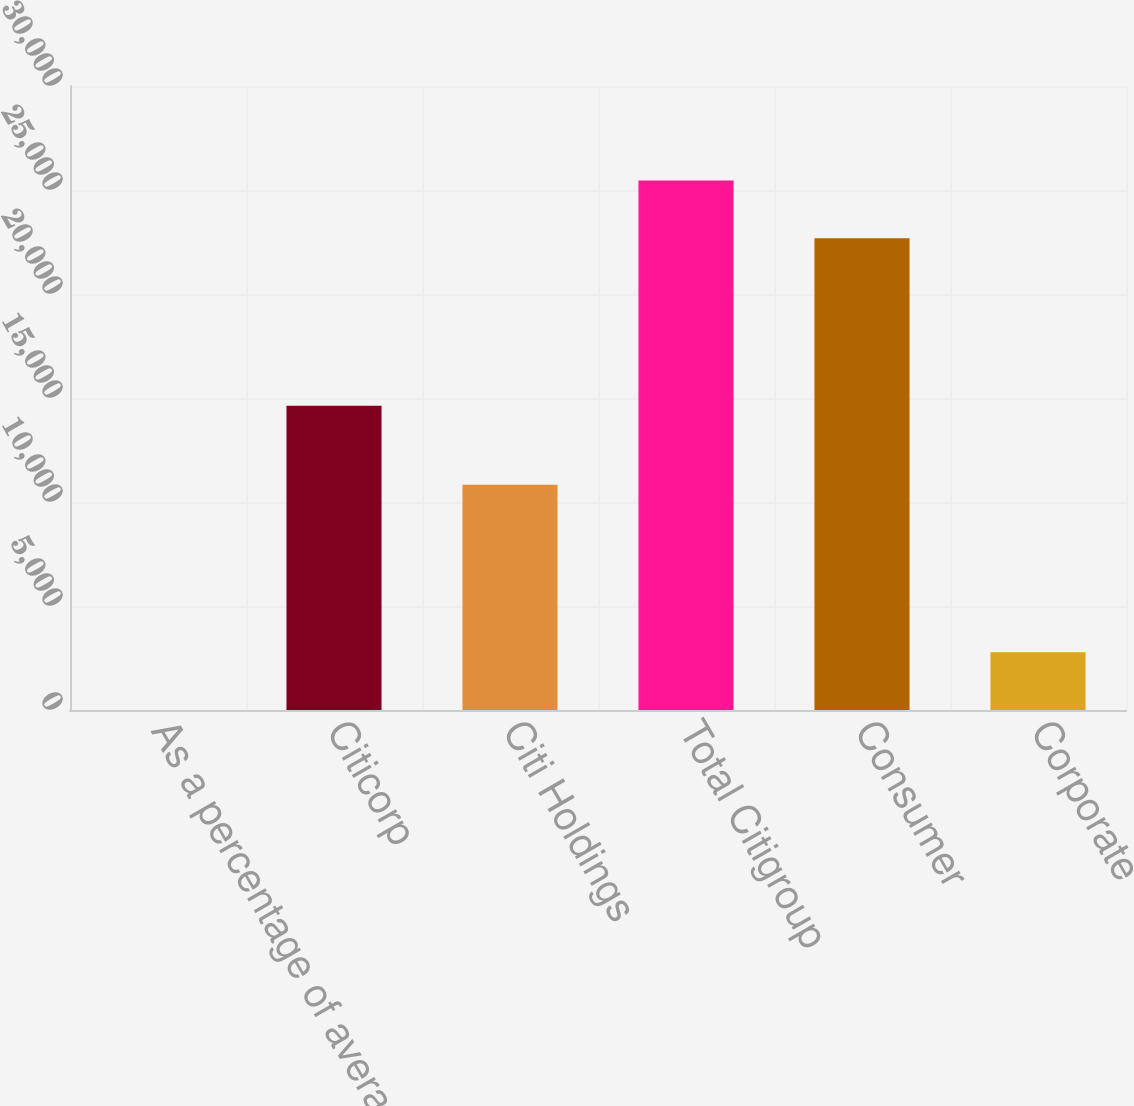<chart> <loc_0><loc_0><loc_500><loc_500><bar_chart><fcel>As a percentage of average<fcel>Citicorp<fcel>Citi Holdings<fcel>Total Citigroup<fcel>Consumer<fcel>Corporate<nl><fcel>0.09<fcel>14623<fcel>10832<fcel>25455<fcel>22679<fcel>2776<nl></chart> 